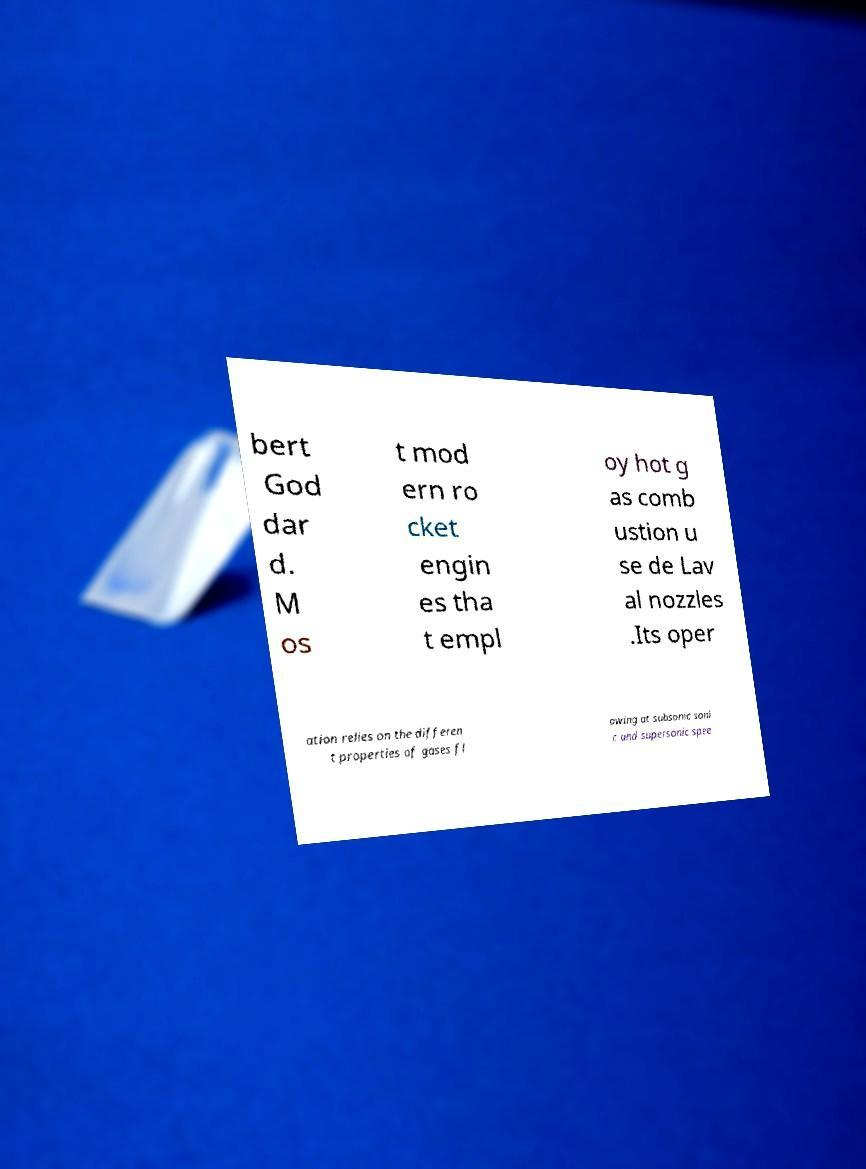Please read and relay the text visible in this image. What does it say? bert God dar d. M os t mod ern ro cket engin es tha t empl oy hot g as comb ustion u se de Lav al nozzles .Its oper ation relies on the differen t properties of gases fl owing at subsonic soni c and supersonic spee 